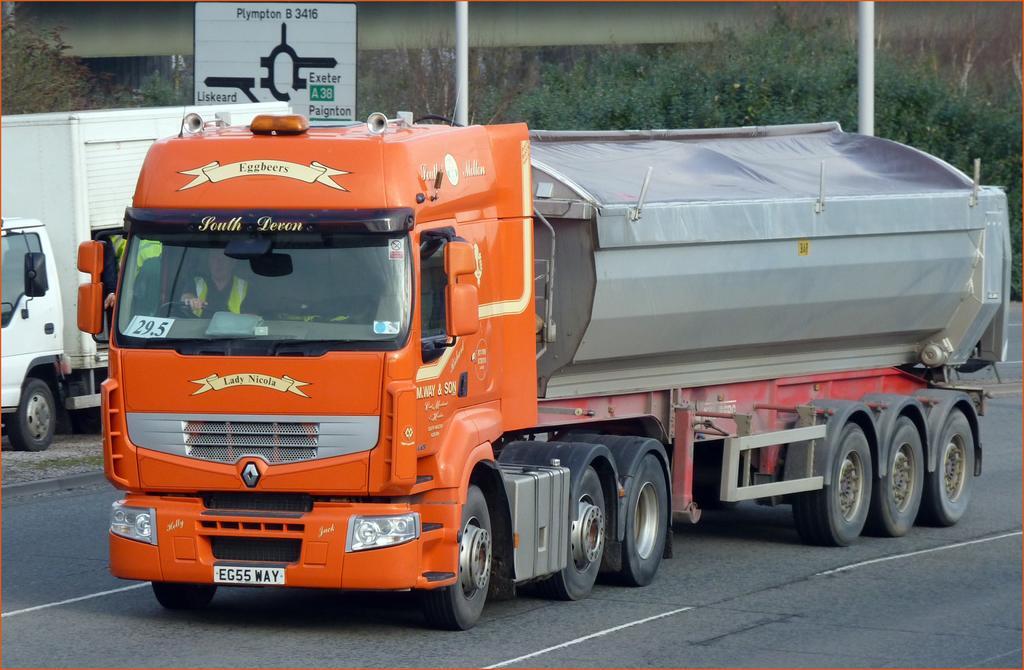Please provide a concise description of this image. This image is clicked on the road. There is a truck moving on the road. Inside the truck there is a person. Behind it there is another truck parked on the ground. In the background there are plants and a sign board. 